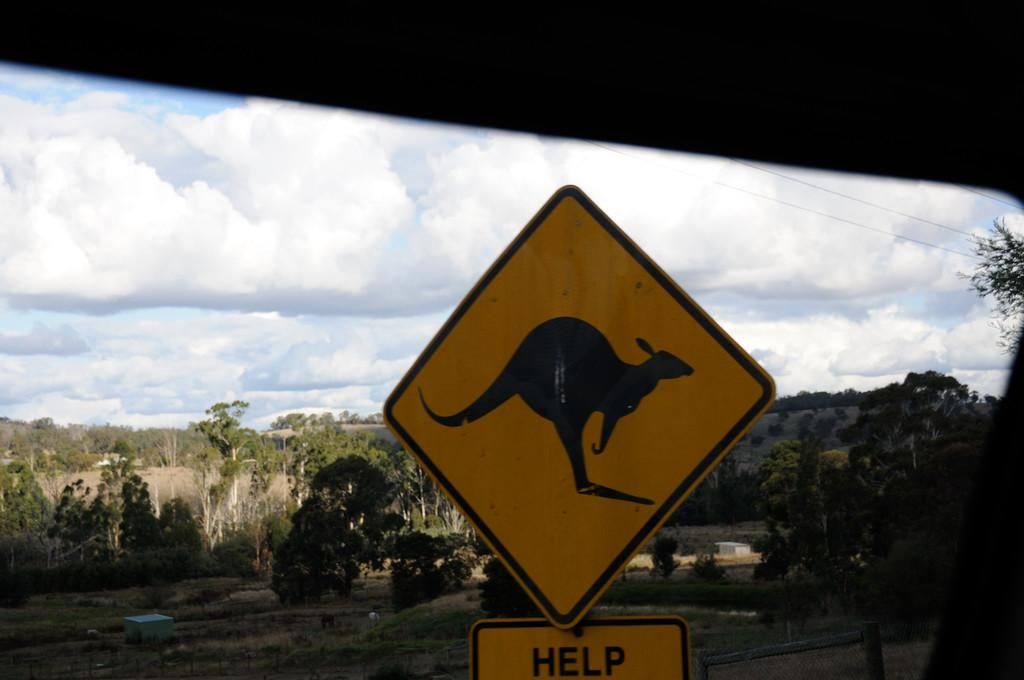<image>
Relay a brief, clear account of the picture shown. A sign of a Kangaroo with another sign that says Help below it. 